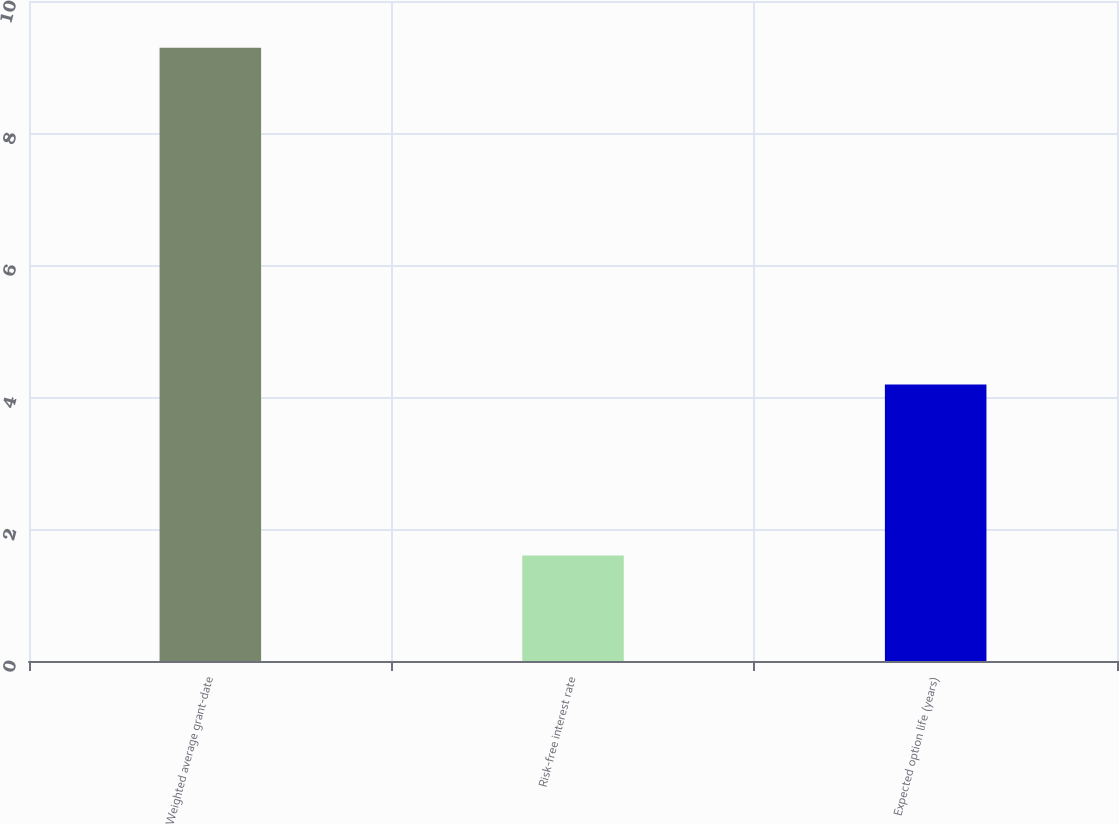Convert chart to OTSL. <chart><loc_0><loc_0><loc_500><loc_500><bar_chart><fcel>Weighted average grant-date<fcel>Risk-free interest rate<fcel>Expected option life (years)<nl><fcel>9.29<fcel>1.6<fcel>4.19<nl></chart> 